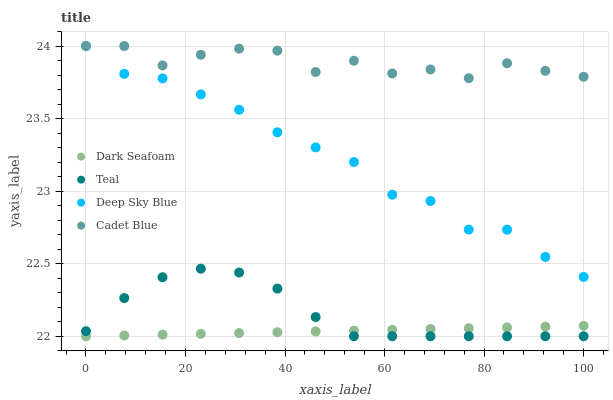Does Dark Seafoam have the minimum area under the curve?
Answer yes or no. Yes. Does Cadet Blue have the maximum area under the curve?
Answer yes or no. Yes. Does Deep Sky Blue have the minimum area under the curve?
Answer yes or no. No. Does Deep Sky Blue have the maximum area under the curve?
Answer yes or no. No. Is Dark Seafoam the smoothest?
Answer yes or no. Yes. Is Cadet Blue the roughest?
Answer yes or no. Yes. Is Deep Sky Blue the smoothest?
Answer yes or no. No. Is Deep Sky Blue the roughest?
Answer yes or no. No. Does Dark Seafoam have the lowest value?
Answer yes or no. Yes. Does Deep Sky Blue have the lowest value?
Answer yes or no. No. Does Deep Sky Blue have the highest value?
Answer yes or no. Yes. Does Teal have the highest value?
Answer yes or no. No. Is Teal less than Cadet Blue?
Answer yes or no. Yes. Is Deep Sky Blue greater than Teal?
Answer yes or no. Yes. Does Dark Seafoam intersect Teal?
Answer yes or no. Yes. Is Dark Seafoam less than Teal?
Answer yes or no. No. Is Dark Seafoam greater than Teal?
Answer yes or no. No. Does Teal intersect Cadet Blue?
Answer yes or no. No. 